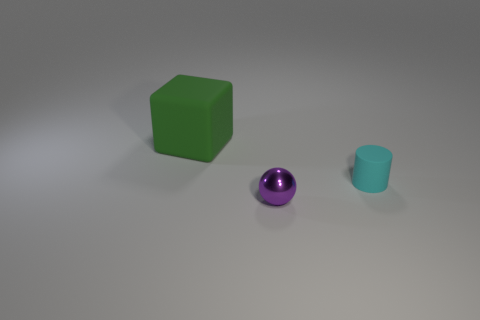Add 1 tiny matte things. How many objects exist? 4 Subtract all cubes. How many objects are left? 2 Subtract all green matte blocks. Subtract all green metal balls. How many objects are left? 2 Add 1 small purple metallic objects. How many small purple metallic objects are left? 2 Add 2 blue rubber blocks. How many blue rubber blocks exist? 2 Subtract 0 blue blocks. How many objects are left? 3 